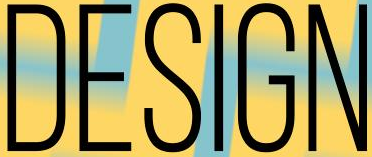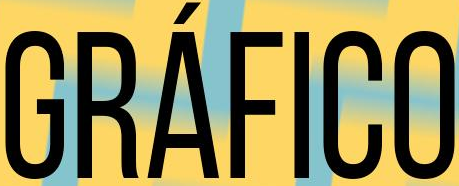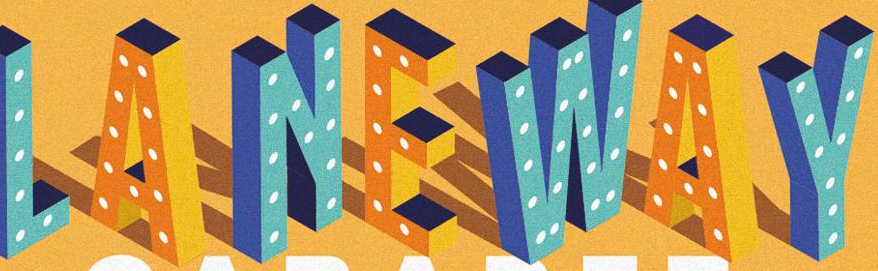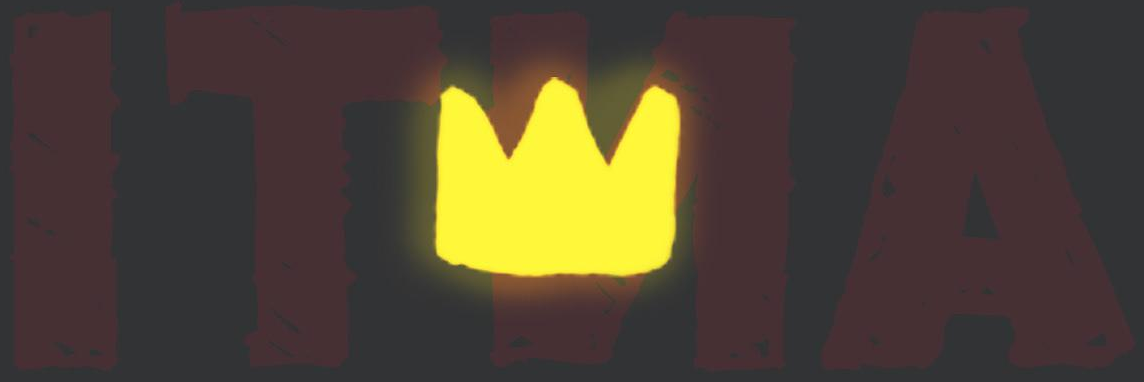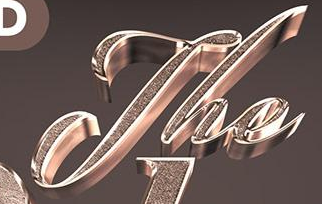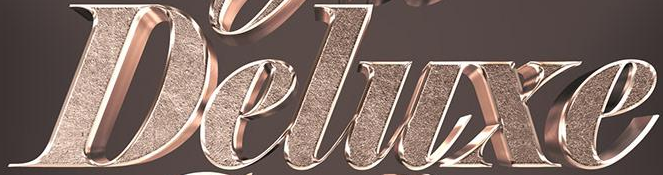Transcribe the words shown in these images in order, separated by a semicolon. DESIGN; GRÁFICO; LANEWAY; ITNA; The; Deluxe 